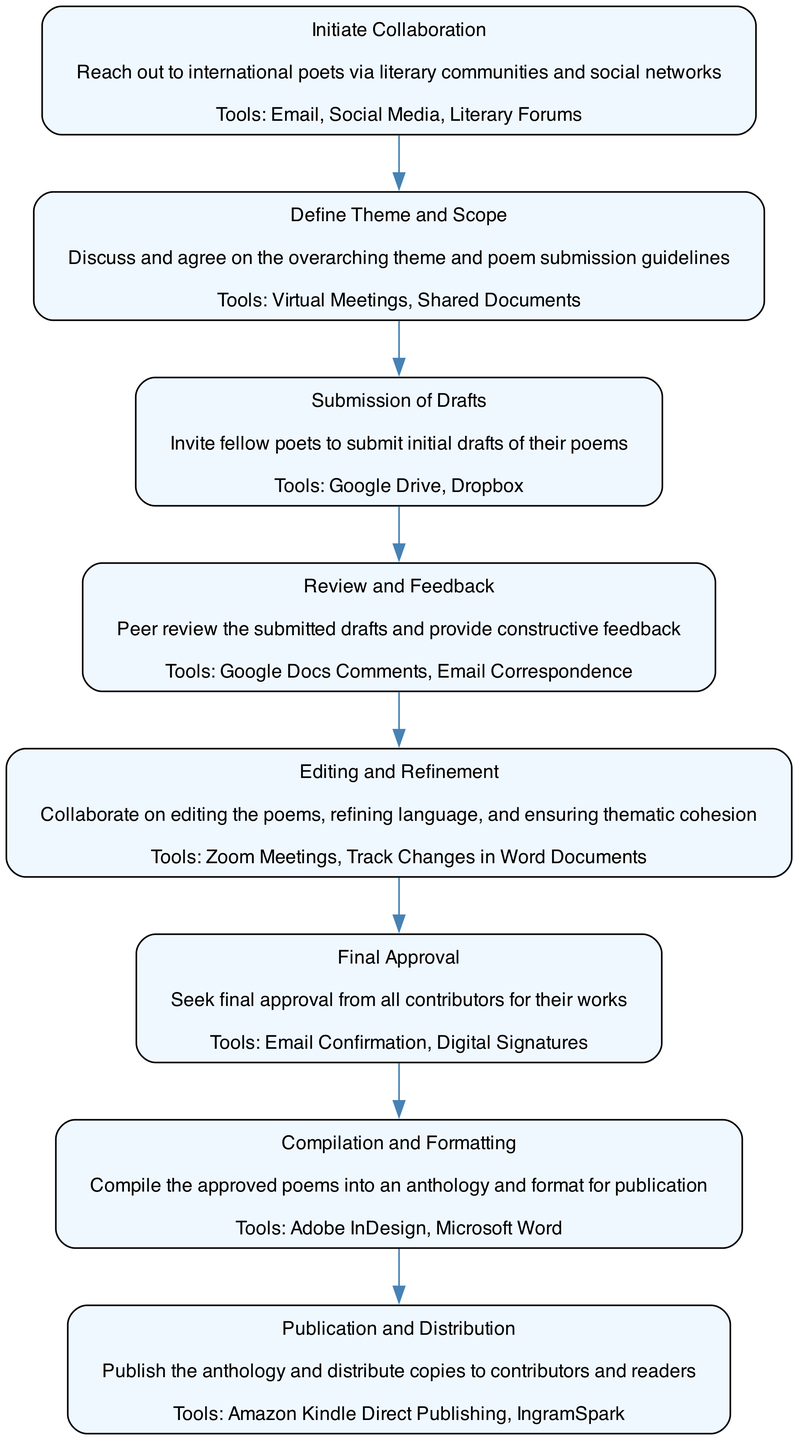What is the first step in collaborating with international writers? The first step listed in the diagram is "Initiate Collaboration," where poets reach out via literary communities and social networks.
Answer: Initiate Collaboration How many tools are mentioned for the theme definition step? The "Define Theme and Scope" step includes two tools: Virtual Meetings and Shared Documents, thus there are two tools.
Answer: 2 What is one tool used for the submission of drafts? In the "Submission of Drafts" step, one of the tools mentioned is Google Drive.
Answer: Google Drive What comes after the "Review and Feedback" step? Following the "Review and Feedback" step in the diagram is the "Editing and Refinement" step, indicating that editing occurs next.
Answer: Editing and Refinement Which step seeks final approval from contributors? The diagram specifies that the "Final Approval" step is dedicated to seeking approval from all contributors for their works.
Answer: Final Approval How many distinct steps are there in the entire process? The diagram outlines eight distinct steps in the process of collaborating on a poetry anthology.
Answer: 8 Which tools are used for formatting the anthology? In the "Compilation and Formatting" step, Adobe InDesign and Microsoft Word are the tools mentioned for formatting the anthology.
Answer: Adobe InDesign, Microsoft Word What is the last step in the process? The final step shown in the diagram is "Publication and Distribution," indicating that the anthology is published and distributed afterwards.
Answer: Publication and Distribution What is the purpose of peer reviewing drafts? The "Review and Feedback" step specifically aims to provide constructive feedback on the submitted drafts, essential for improving the poetry.
Answer: Constructive feedback 